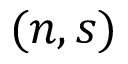<formula> <loc_0><loc_0><loc_500><loc_500>( n , s )</formula> 